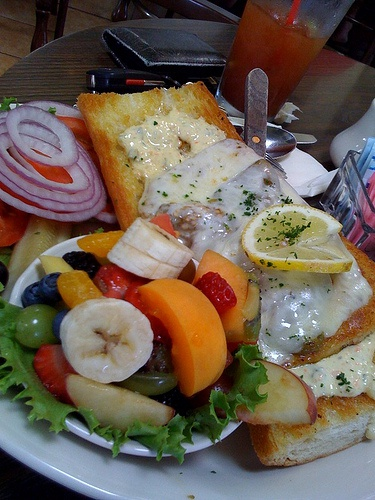Describe the objects in this image and their specific colors. I can see dining table in darkgray, black, maroon, and gray tones, sandwich in black, darkgray, tan, olive, and gray tones, banana in black, darkgray, and gray tones, cup in black, maroon, and gray tones, and apple in black, gray, and darkgreen tones in this image. 